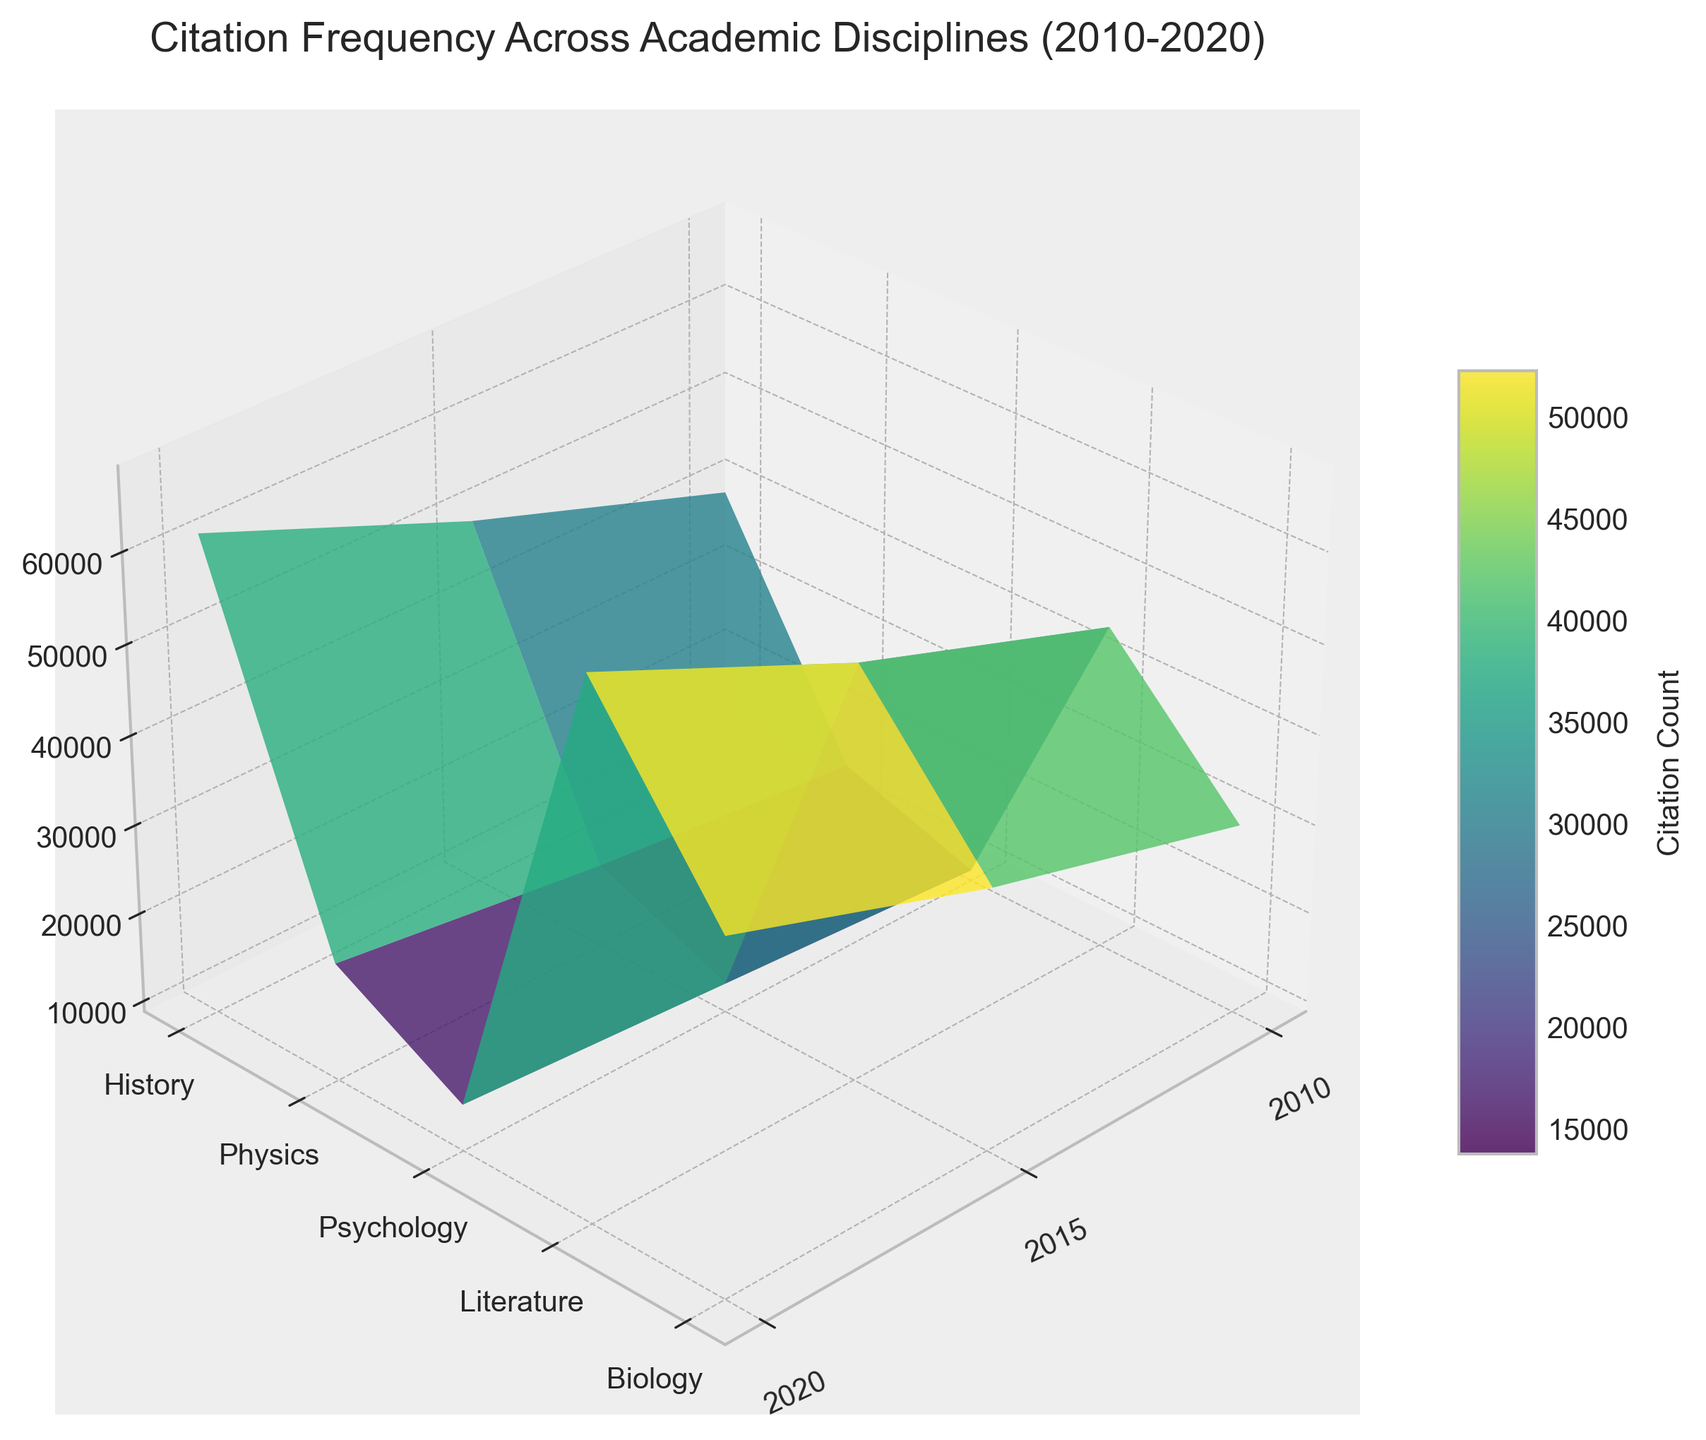Which discipline had the highest citation count in 2020? Look at the surface plot around the year 2020 and identify the highest point. Physics shows the highest peak for that year.
Answer: Physics How many years are represented in the figure? Look at the x-axis, which shows the years. By counting the unique labels on the x-axis, we can see there are three years: 2010, 2015, and 2020.
Answer: 3 What's the range of citation counts for Biology? Locate the curve corresponding to Biology and observe the vertical distance it spans from 2010 to 2020. The minimum value is 40,000 and the maximum is 62,000.
Answer: 40,000 to 62,000 Which year saw the highest overall citation count across all disciplines? Compare the surface heights for each year and sum these values. The year with the highest summed value of all disciplines is 2020.
Answer: 2020 By how much did citations in Literature increase from 2010 to 2020? Locate the points for Literature on the surface plot for 2010 and 2020. Subtract the value for 2010 (10,000) from the value for 2020 (14,000).
Answer: 4,000 Which discipline experienced the least growth in citation count from 2010 to 2020? Look at the change in height from 2010 to 2020 for each discipline. Literature shows the smallest increase in vertical height compared to others.
Answer: Literature What's the average citation count for Psychology over the years? Sum the citation counts for Psychology for the years 2010, 2015, and 2020: (30,000 + 38,000 + 48,000), and divide by 3.
Answer: 38,667 In 2015, how did the citation count for History compare to that of Biology? Find the points for both History and Biology in 2015 on the surface plot. History has 18,000 citations and Biology has 50,000 citations. History's citations are much lower.
Answer: Lower Which disciplines showed a continuous increase in citations over the years? Look at the individual curves for each discipline and note the disciplines that consistently move upwards without any decrease. Both Biology and Physics show a continuous increase.
Answer: Biology, Physics Is there a significant difference in citation counts between the humanities and sciences in 2020? Compare the peaks for History and Literature (humanities) against Physics, Biology, and Psychology (sciences) in 2020. Humanities have significantly lower peak values.
Answer: Yes 